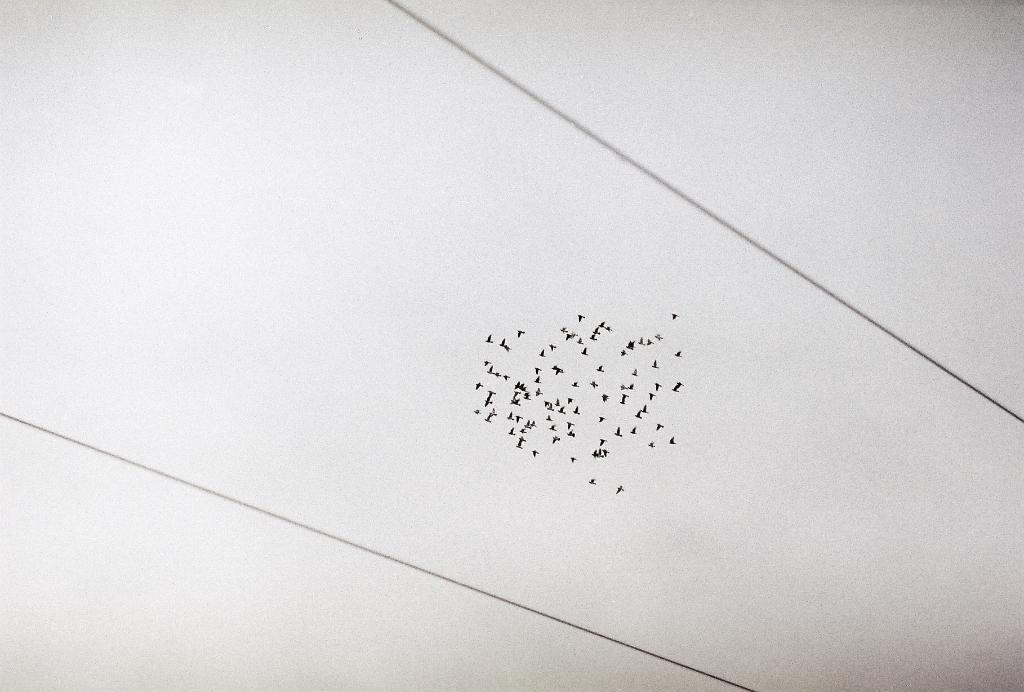What is the main subject of the image? The main subject of the image is a group of birds. What are the birds doing in the image? The birds are flying in the air. What can be seen in the background of the image? The sky is visible in the image. Are there any man-made structures in the image? Yes, there are wires in the image. What does the caption on the image say about the birds? There is no caption present in the image, so it cannot be determined what it might say about the birds. Can you describe the smell of the birds in the image? There is no mention of smell in the image, and it is not possible to determine the smell of the birds from the visual information provided. 